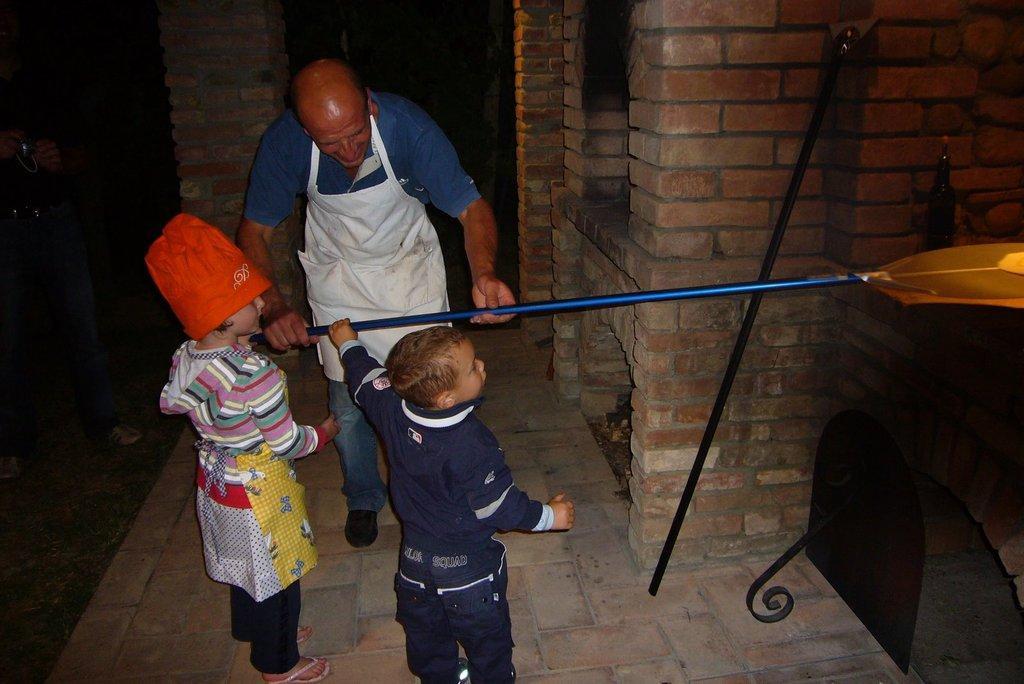Can you describe this image briefly? In this image we can see a person and two kids who are holding stick and a person wearing chef suit which is of white color and a kid wearing red color cap and at the background of the image there is brick wall. 